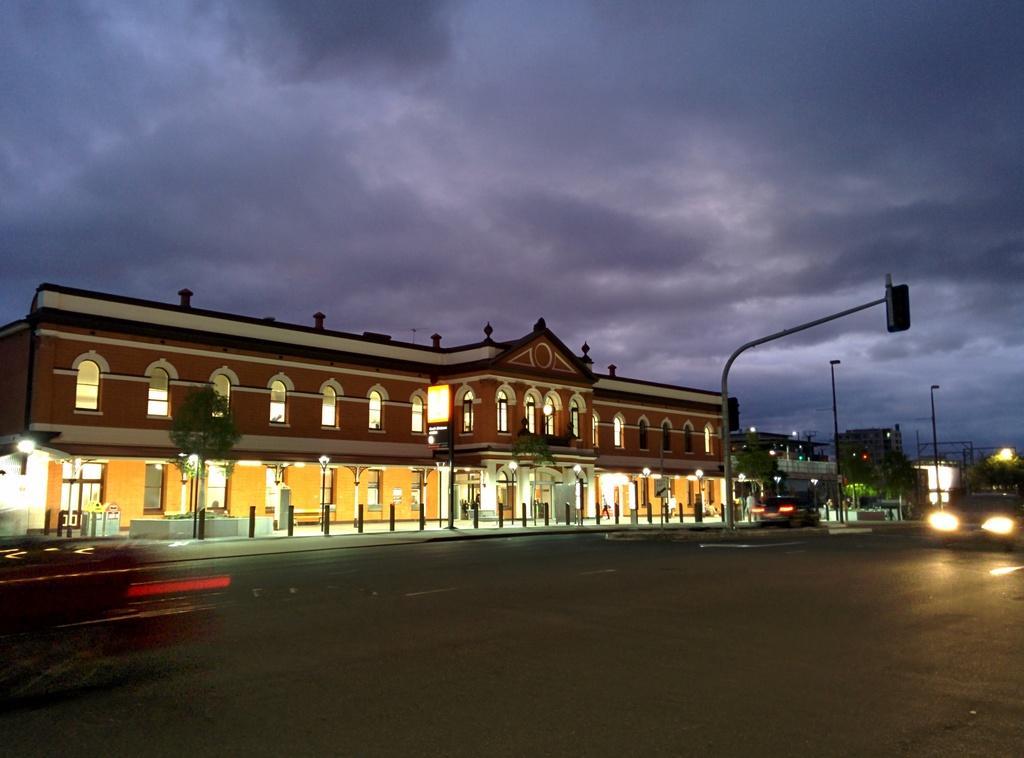Please provide a concise description of this image. In this image in the middle I can see a road , on the road I can see vehicles and street light pole and traffic signal light and building , in front of the building I can see trees and lights visible ,at the top I can see the sky and the sky is cloudy. 